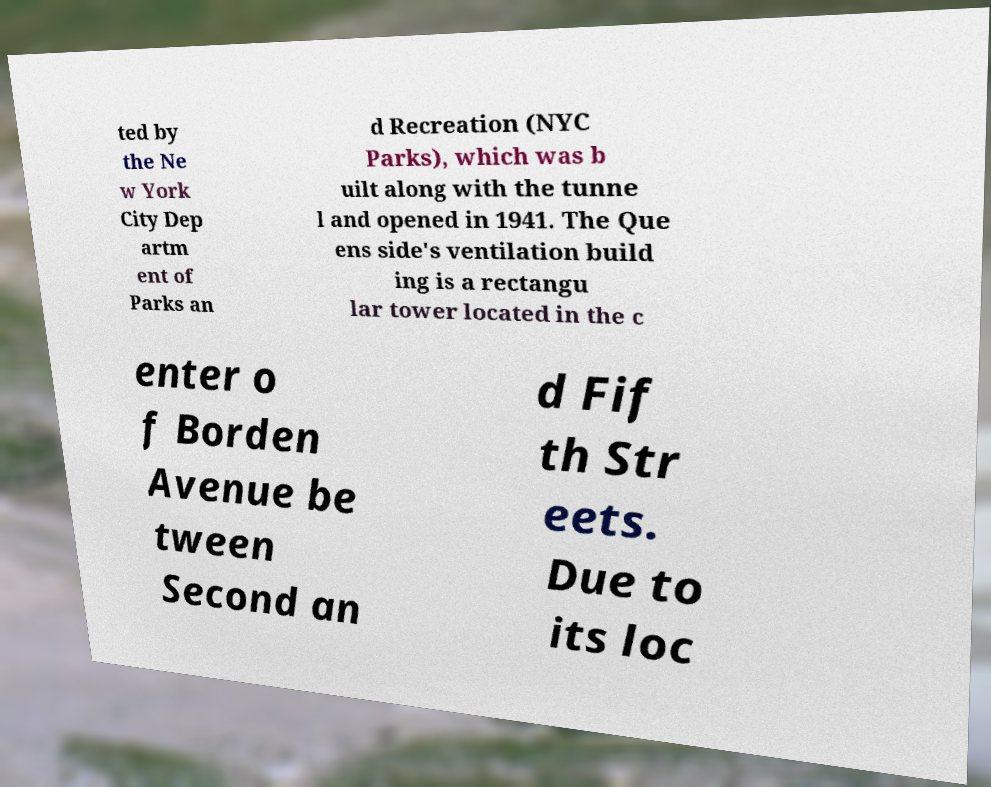What messages or text are displayed in this image? I need them in a readable, typed format. ted by the Ne w York City Dep artm ent of Parks an d Recreation (NYC Parks), which was b uilt along with the tunne l and opened in 1941. The Que ens side's ventilation build ing is a rectangu lar tower located in the c enter o f Borden Avenue be tween Second an d Fif th Str eets. Due to its loc 